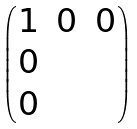<formula> <loc_0><loc_0><loc_500><loc_500>\begin{pmatrix} 1 & 0 & 0 \\ 0 & & \\ 0 & & \end{pmatrix}</formula> 